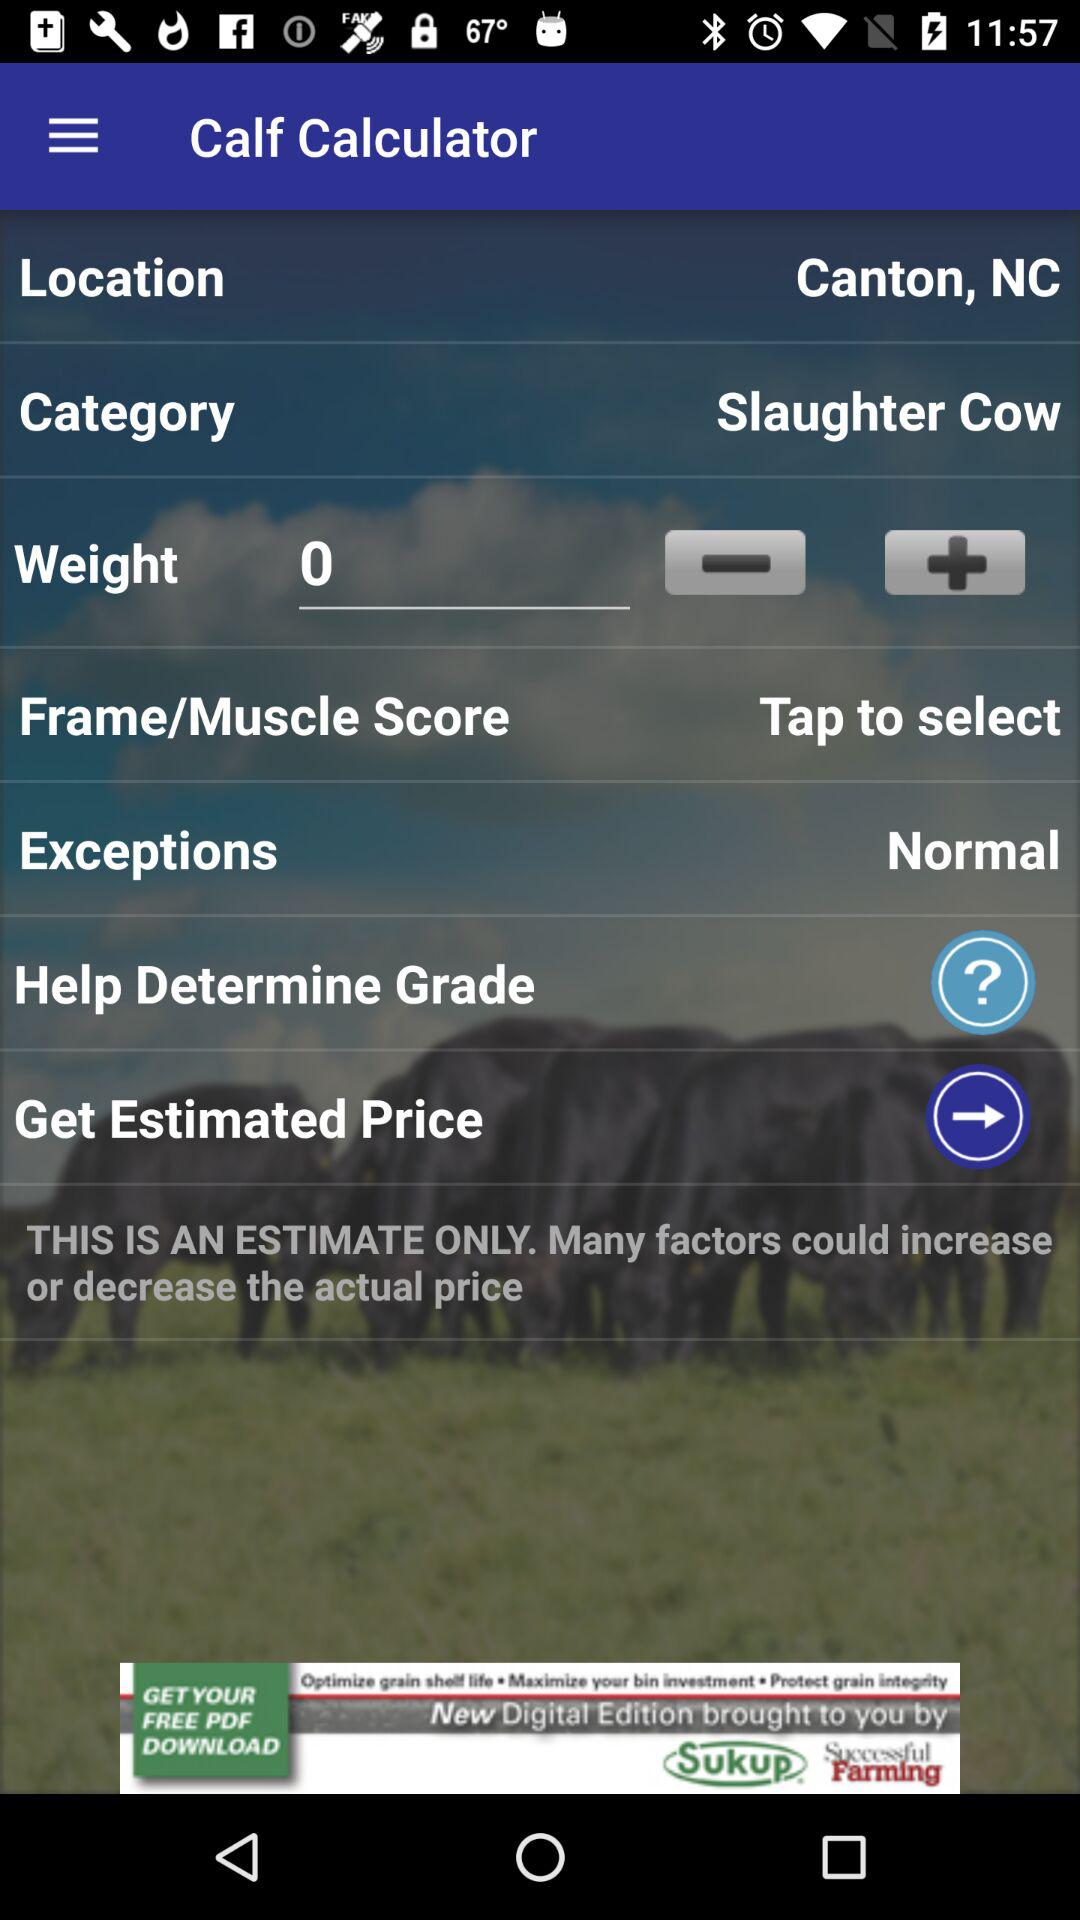What is the category? The category is "Slaughter Cow". 